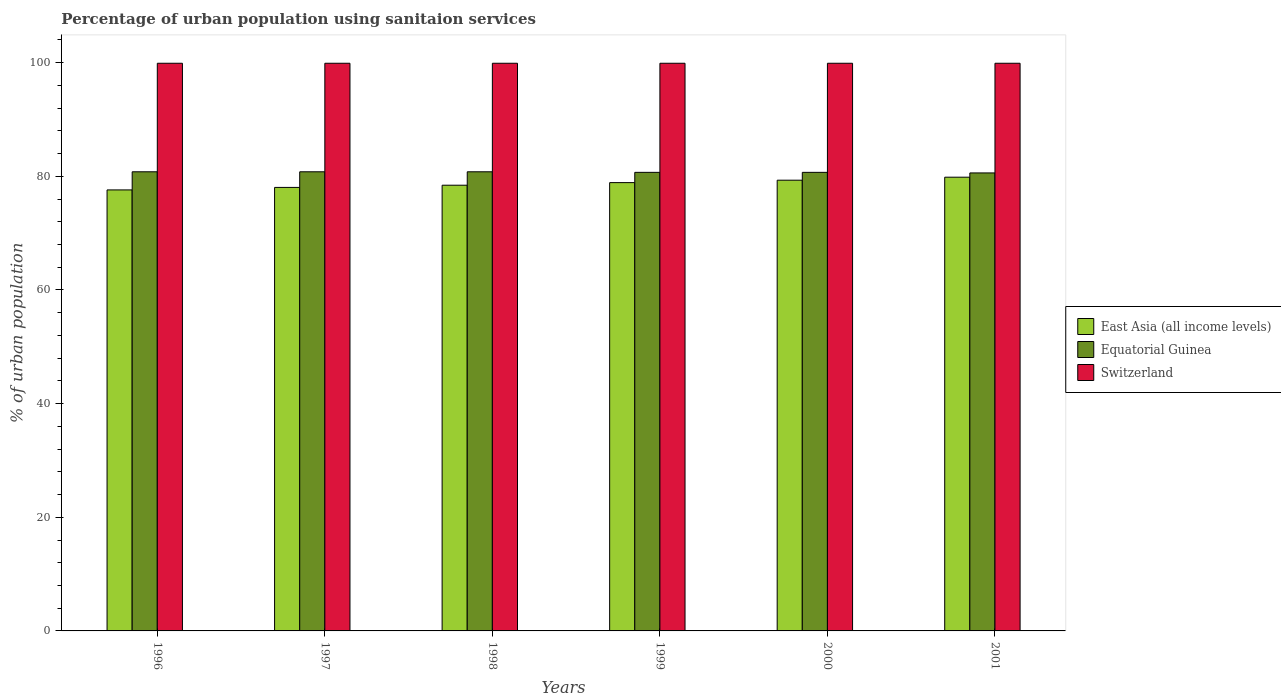How many groups of bars are there?
Offer a terse response. 6. What is the label of the 1st group of bars from the left?
Make the answer very short. 1996. What is the percentage of urban population using sanitaion services in Switzerland in 1998?
Your answer should be very brief. 99.9. Across all years, what is the maximum percentage of urban population using sanitaion services in East Asia (all income levels)?
Offer a very short reply. 79.85. Across all years, what is the minimum percentage of urban population using sanitaion services in Switzerland?
Provide a succinct answer. 99.9. In which year was the percentage of urban population using sanitaion services in Equatorial Guinea maximum?
Provide a succinct answer. 1996. What is the total percentage of urban population using sanitaion services in Switzerland in the graph?
Your answer should be very brief. 599.4. What is the difference between the percentage of urban population using sanitaion services in Equatorial Guinea in 1998 and that in 1999?
Your answer should be compact. 0.1. What is the difference between the percentage of urban population using sanitaion services in Switzerland in 1998 and the percentage of urban population using sanitaion services in East Asia (all income levels) in 1999?
Offer a very short reply. 21. What is the average percentage of urban population using sanitaion services in Equatorial Guinea per year?
Provide a succinct answer. 80.73. In the year 1999, what is the difference between the percentage of urban population using sanitaion services in Equatorial Guinea and percentage of urban population using sanitaion services in Switzerland?
Ensure brevity in your answer.  -19.2. In how many years, is the percentage of urban population using sanitaion services in East Asia (all income levels) greater than 20 %?
Offer a terse response. 6. What is the ratio of the percentage of urban population using sanitaion services in East Asia (all income levels) in 1999 to that in 2001?
Your answer should be very brief. 0.99. Is the percentage of urban population using sanitaion services in Switzerland in 1999 less than that in 2001?
Provide a short and direct response. No. Is the difference between the percentage of urban population using sanitaion services in Equatorial Guinea in 1999 and 2000 greater than the difference between the percentage of urban population using sanitaion services in Switzerland in 1999 and 2000?
Keep it short and to the point. No. What is the difference between the highest and the lowest percentage of urban population using sanitaion services in Switzerland?
Make the answer very short. 0. In how many years, is the percentage of urban population using sanitaion services in Equatorial Guinea greater than the average percentage of urban population using sanitaion services in Equatorial Guinea taken over all years?
Give a very brief answer. 3. What does the 2nd bar from the left in 2000 represents?
Offer a very short reply. Equatorial Guinea. What does the 2nd bar from the right in 2000 represents?
Make the answer very short. Equatorial Guinea. How many bars are there?
Ensure brevity in your answer.  18. How many years are there in the graph?
Ensure brevity in your answer.  6. What is the difference between two consecutive major ticks on the Y-axis?
Your answer should be very brief. 20. Does the graph contain any zero values?
Offer a very short reply. No. Where does the legend appear in the graph?
Keep it short and to the point. Center right. How many legend labels are there?
Provide a short and direct response. 3. What is the title of the graph?
Provide a succinct answer. Percentage of urban population using sanitaion services. What is the label or title of the X-axis?
Your response must be concise. Years. What is the label or title of the Y-axis?
Your answer should be very brief. % of urban population. What is the % of urban population of East Asia (all income levels) in 1996?
Offer a very short reply. 77.61. What is the % of urban population in Equatorial Guinea in 1996?
Ensure brevity in your answer.  80.8. What is the % of urban population in Switzerland in 1996?
Your answer should be very brief. 99.9. What is the % of urban population in East Asia (all income levels) in 1997?
Your response must be concise. 78.05. What is the % of urban population in Equatorial Guinea in 1997?
Provide a short and direct response. 80.8. What is the % of urban population of Switzerland in 1997?
Your response must be concise. 99.9. What is the % of urban population of East Asia (all income levels) in 1998?
Your answer should be very brief. 78.44. What is the % of urban population in Equatorial Guinea in 1998?
Ensure brevity in your answer.  80.8. What is the % of urban population in Switzerland in 1998?
Keep it short and to the point. 99.9. What is the % of urban population of East Asia (all income levels) in 1999?
Your response must be concise. 78.9. What is the % of urban population in Equatorial Guinea in 1999?
Your answer should be compact. 80.7. What is the % of urban population of Switzerland in 1999?
Your answer should be compact. 99.9. What is the % of urban population of East Asia (all income levels) in 2000?
Provide a succinct answer. 79.32. What is the % of urban population of Equatorial Guinea in 2000?
Provide a succinct answer. 80.7. What is the % of urban population in Switzerland in 2000?
Offer a terse response. 99.9. What is the % of urban population in East Asia (all income levels) in 2001?
Your response must be concise. 79.85. What is the % of urban population of Equatorial Guinea in 2001?
Offer a very short reply. 80.6. What is the % of urban population of Switzerland in 2001?
Give a very brief answer. 99.9. Across all years, what is the maximum % of urban population in East Asia (all income levels)?
Offer a very short reply. 79.85. Across all years, what is the maximum % of urban population in Equatorial Guinea?
Ensure brevity in your answer.  80.8. Across all years, what is the maximum % of urban population of Switzerland?
Offer a very short reply. 99.9. Across all years, what is the minimum % of urban population in East Asia (all income levels)?
Provide a succinct answer. 77.61. Across all years, what is the minimum % of urban population of Equatorial Guinea?
Give a very brief answer. 80.6. Across all years, what is the minimum % of urban population of Switzerland?
Keep it short and to the point. 99.9. What is the total % of urban population of East Asia (all income levels) in the graph?
Offer a terse response. 472.17. What is the total % of urban population in Equatorial Guinea in the graph?
Ensure brevity in your answer.  484.4. What is the total % of urban population of Switzerland in the graph?
Offer a terse response. 599.4. What is the difference between the % of urban population in East Asia (all income levels) in 1996 and that in 1997?
Provide a short and direct response. -0.44. What is the difference between the % of urban population in Equatorial Guinea in 1996 and that in 1997?
Your response must be concise. 0. What is the difference between the % of urban population in East Asia (all income levels) in 1996 and that in 1998?
Provide a short and direct response. -0.83. What is the difference between the % of urban population in Equatorial Guinea in 1996 and that in 1998?
Give a very brief answer. 0. What is the difference between the % of urban population in East Asia (all income levels) in 1996 and that in 1999?
Your response must be concise. -1.28. What is the difference between the % of urban population of Switzerland in 1996 and that in 1999?
Your answer should be very brief. 0. What is the difference between the % of urban population in East Asia (all income levels) in 1996 and that in 2000?
Give a very brief answer. -1.71. What is the difference between the % of urban population of Switzerland in 1996 and that in 2000?
Offer a terse response. 0. What is the difference between the % of urban population in East Asia (all income levels) in 1996 and that in 2001?
Provide a succinct answer. -2.24. What is the difference between the % of urban population in Equatorial Guinea in 1996 and that in 2001?
Keep it short and to the point. 0.2. What is the difference between the % of urban population of Switzerland in 1996 and that in 2001?
Provide a succinct answer. 0. What is the difference between the % of urban population of East Asia (all income levels) in 1997 and that in 1998?
Your answer should be compact. -0.39. What is the difference between the % of urban population of East Asia (all income levels) in 1997 and that in 1999?
Provide a succinct answer. -0.85. What is the difference between the % of urban population in Equatorial Guinea in 1997 and that in 1999?
Your response must be concise. 0.1. What is the difference between the % of urban population in East Asia (all income levels) in 1997 and that in 2000?
Make the answer very short. -1.27. What is the difference between the % of urban population in Equatorial Guinea in 1997 and that in 2000?
Keep it short and to the point. 0.1. What is the difference between the % of urban population in East Asia (all income levels) in 1997 and that in 2001?
Your answer should be compact. -1.8. What is the difference between the % of urban population of Equatorial Guinea in 1997 and that in 2001?
Your answer should be very brief. 0.2. What is the difference between the % of urban population of East Asia (all income levels) in 1998 and that in 1999?
Offer a very short reply. -0.46. What is the difference between the % of urban population of Switzerland in 1998 and that in 1999?
Your answer should be compact. 0. What is the difference between the % of urban population of East Asia (all income levels) in 1998 and that in 2000?
Ensure brevity in your answer.  -0.88. What is the difference between the % of urban population in Switzerland in 1998 and that in 2000?
Your answer should be compact. 0. What is the difference between the % of urban population in East Asia (all income levels) in 1998 and that in 2001?
Ensure brevity in your answer.  -1.41. What is the difference between the % of urban population of Equatorial Guinea in 1998 and that in 2001?
Ensure brevity in your answer.  0.2. What is the difference between the % of urban population of Switzerland in 1998 and that in 2001?
Ensure brevity in your answer.  0. What is the difference between the % of urban population in East Asia (all income levels) in 1999 and that in 2000?
Make the answer very short. -0.43. What is the difference between the % of urban population in Equatorial Guinea in 1999 and that in 2000?
Keep it short and to the point. 0. What is the difference between the % of urban population of Switzerland in 1999 and that in 2000?
Your answer should be compact. 0. What is the difference between the % of urban population in East Asia (all income levels) in 1999 and that in 2001?
Make the answer very short. -0.95. What is the difference between the % of urban population in East Asia (all income levels) in 2000 and that in 2001?
Your response must be concise. -0.53. What is the difference between the % of urban population of Switzerland in 2000 and that in 2001?
Provide a succinct answer. 0. What is the difference between the % of urban population of East Asia (all income levels) in 1996 and the % of urban population of Equatorial Guinea in 1997?
Your answer should be very brief. -3.19. What is the difference between the % of urban population of East Asia (all income levels) in 1996 and the % of urban population of Switzerland in 1997?
Ensure brevity in your answer.  -22.29. What is the difference between the % of urban population of Equatorial Guinea in 1996 and the % of urban population of Switzerland in 1997?
Offer a very short reply. -19.1. What is the difference between the % of urban population of East Asia (all income levels) in 1996 and the % of urban population of Equatorial Guinea in 1998?
Your answer should be compact. -3.19. What is the difference between the % of urban population of East Asia (all income levels) in 1996 and the % of urban population of Switzerland in 1998?
Offer a very short reply. -22.29. What is the difference between the % of urban population of Equatorial Guinea in 1996 and the % of urban population of Switzerland in 1998?
Offer a very short reply. -19.1. What is the difference between the % of urban population of East Asia (all income levels) in 1996 and the % of urban population of Equatorial Guinea in 1999?
Ensure brevity in your answer.  -3.09. What is the difference between the % of urban population in East Asia (all income levels) in 1996 and the % of urban population in Switzerland in 1999?
Your answer should be very brief. -22.29. What is the difference between the % of urban population in Equatorial Guinea in 1996 and the % of urban population in Switzerland in 1999?
Your answer should be very brief. -19.1. What is the difference between the % of urban population of East Asia (all income levels) in 1996 and the % of urban population of Equatorial Guinea in 2000?
Your response must be concise. -3.09. What is the difference between the % of urban population in East Asia (all income levels) in 1996 and the % of urban population in Switzerland in 2000?
Your answer should be compact. -22.29. What is the difference between the % of urban population in Equatorial Guinea in 1996 and the % of urban population in Switzerland in 2000?
Ensure brevity in your answer.  -19.1. What is the difference between the % of urban population of East Asia (all income levels) in 1996 and the % of urban population of Equatorial Guinea in 2001?
Ensure brevity in your answer.  -2.99. What is the difference between the % of urban population in East Asia (all income levels) in 1996 and the % of urban population in Switzerland in 2001?
Make the answer very short. -22.29. What is the difference between the % of urban population of Equatorial Guinea in 1996 and the % of urban population of Switzerland in 2001?
Offer a terse response. -19.1. What is the difference between the % of urban population in East Asia (all income levels) in 1997 and the % of urban population in Equatorial Guinea in 1998?
Keep it short and to the point. -2.75. What is the difference between the % of urban population in East Asia (all income levels) in 1997 and the % of urban population in Switzerland in 1998?
Provide a short and direct response. -21.85. What is the difference between the % of urban population in Equatorial Guinea in 1997 and the % of urban population in Switzerland in 1998?
Offer a very short reply. -19.1. What is the difference between the % of urban population in East Asia (all income levels) in 1997 and the % of urban population in Equatorial Guinea in 1999?
Provide a short and direct response. -2.65. What is the difference between the % of urban population of East Asia (all income levels) in 1997 and the % of urban population of Switzerland in 1999?
Keep it short and to the point. -21.85. What is the difference between the % of urban population in Equatorial Guinea in 1997 and the % of urban population in Switzerland in 1999?
Keep it short and to the point. -19.1. What is the difference between the % of urban population in East Asia (all income levels) in 1997 and the % of urban population in Equatorial Guinea in 2000?
Offer a terse response. -2.65. What is the difference between the % of urban population of East Asia (all income levels) in 1997 and the % of urban population of Switzerland in 2000?
Your answer should be very brief. -21.85. What is the difference between the % of urban population in Equatorial Guinea in 1997 and the % of urban population in Switzerland in 2000?
Your response must be concise. -19.1. What is the difference between the % of urban population in East Asia (all income levels) in 1997 and the % of urban population in Equatorial Guinea in 2001?
Offer a terse response. -2.55. What is the difference between the % of urban population in East Asia (all income levels) in 1997 and the % of urban population in Switzerland in 2001?
Ensure brevity in your answer.  -21.85. What is the difference between the % of urban population in Equatorial Guinea in 1997 and the % of urban population in Switzerland in 2001?
Ensure brevity in your answer.  -19.1. What is the difference between the % of urban population in East Asia (all income levels) in 1998 and the % of urban population in Equatorial Guinea in 1999?
Your answer should be compact. -2.26. What is the difference between the % of urban population of East Asia (all income levels) in 1998 and the % of urban population of Switzerland in 1999?
Your answer should be compact. -21.46. What is the difference between the % of urban population in Equatorial Guinea in 1998 and the % of urban population in Switzerland in 1999?
Your answer should be very brief. -19.1. What is the difference between the % of urban population in East Asia (all income levels) in 1998 and the % of urban population in Equatorial Guinea in 2000?
Provide a short and direct response. -2.26. What is the difference between the % of urban population of East Asia (all income levels) in 1998 and the % of urban population of Switzerland in 2000?
Your answer should be compact. -21.46. What is the difference between the % of urban population of Equatorial Guinea in 1998 and the % of urban population of Switzerland in 2000?
Offer a terse response. -19.1. What is the difference between the % of urban population in East Asia (all income levels) in 1998 and the % of urban population in Equatorial Guinea in 2001?
Keep it short and to the point. -2.16. What is the difference between the % of urban population of East Asia (all income levels) in 1998 and the % of urban population of Switzerland in 2001?
Make the answer very short. -21.46. What is the difference between the % of urban population of Equatorial Guinea in 1998 and the % of urban population of Switzerland in 2001?
Provide a short and direct response. -19.1. What is the difference between the % of urban population of East Asia (all income levels) in 1999 and the % of urban population of Equatorial Guinea in 2000?
Give a very brief answer. -1.8. What is the difference between the % of urban population of East Asia (all income levels) in 1999 and the % of urban population of Switzerland in 2000?
Your response must be concise. -21. What is the difference between the % of urban population of Equatorial Guinea in 1999 and the % of urban population of Switzerland in 2000?
Make the answer very short. -19.2. What is the difference between the % of urban population of East Asia (all income levels) in 1999 and the % of urban population of Equatorial Guinea in 2001?
Make the answer very short. -1.7. What is the difference between the % of urban population of East Asia (all income levels) in 1999 and the % of urban population of Switzerland in 2001?
Ensure brevity in your answer.  -21. What is the difference between the % of urban population of Equatorial Guinea in 1999 and the % of urban population of Switzerland in 2001?
Ensure brevity in your answer.  -19.2. What is the difference between the % of urban population in East Asia (all income levels) in 2000 and the % of urban population in Equatorial Guinea in 2001?
Ensure brevity in your answer.  -1.28. What is the difference between the % of urban population of East Asia (all income levels) in 2000 and the % of urban population of Switzerland in 2001?
Your response must be concise. -20.58. What is the difference between the % of urban population in Equatorial Guinea in 2000 and the % of urban population in Switzerland in 2001?
Keep it short and to the point. -19.2. What is the average % of urban population of East Asia (all income levels) per year?
Keep it short and to the point. 78.69. What is the average % of urban population in Equatorial Guinea per year?
Ensure brevity in your answer.  80.73. What is the average % of urban population of Switzerland per year?
Your response must be concise. 99.9. In the year 1996, what is the difference between the % of urban population of East Asia (all income levels) and % of urban population of Equatorial Guinea?
Keep it short and to the point. -3.19. In the year 1996, what is the difference between the % of urban population of East Asia (all income levels) and % of urban population of Switzerland?
Offer a terse response. -22.29. In the year 1996, what is the difference between the % of urban population in Equatorial Guinea and % of urban population in Switzerland?
Offer a very short reply. -19.1. In the year 1997, what is the difference between the % of urban population in East Asia (all income levels) and % of urban population in Equatorial Guinea?
Your response must be concise. -2.75. In the year 1997, what is the difference between the % of urban population in East Asia (all income levels) and % of urban population in Switzerland?
Offer a terse response. -21.85. In the year 1997, what is the difference between the % of urban population in Equatorial Guinea and % of urban population in Switzerland?
Provide a short and direct response. -19.1. In the year 1998, what is the difference between the % of urban population in East Asia (all income levels) and % of urban population in Equatorial Guinea?
Offer a very short reply. -2.36. In the year 1998, what is the difference between the % of urban population of East Asia (all income levels) and % of urban population of Switzerland?
Offer a very short reply. -21.46. In the year 1998, what is the difference between the % of urban population in Equatorial Guinea and % of urban population in Switzerland?
Provide a short and direct response. -19.1. In the year 1999, what is the difference between the % of urban population of East Asia (all income levels) and % of urban population of Equatorial Guinea?
Provide a short and direct response. -1.8. In the year 1999, what is the difference between the % of urban population in East Asia (all income levels) and % of urban population in Switzerland?
Your answer should be compact. -21. In the year 1999, what is the difference between the % of urban population of Equatorial Guinea and % of urban population of Switzerland?
Your answer should be very brief. -19.2. In the year 2000, what is the difference between the % of urban population in East Asia (all income levels) and % of urban population in Equatorial Guinea?
Keep it short and to the point. -1.38. In the year 2000, what is the difference between the % of urban population in East Asia (all income levels) and % of urban population in Switzerland?
Make the answer very short. -20.58. In the year 2000, what is the difference between the % of urban population in Equatorial Guinea and % of urban population in Switzerland?
Your response must be concise. -19.2. In the year 2001, what is the difference between the % of urban population of East Asia (all income levels) and % of urban population of Equatorial Guinea?
Offer a terse response. -0.75. In the year 2001, what is the difference between the % of urban population of East Asia (all income levels) and % of urban population of Switzerland?
Provide a succinct answer. -20.05. In the year 2001, what is the difference between the % of urban population of Equatorial Guinea and % of urban population of Switzerland?
Provide a succinct answer. -19.3. What is the ratio of the % of urban population of East Asia (all income levels) in 1996 to that in 1997?
Your response must be concise. 0.99. What is the ratio of the % of urban population of Switzerland in 1996 to that in 1997?
Offer a very short reply. 1. What is the ratio of the % of urban population in Equatorial Guinea in 1996 to that in 1998?
Your answer should be compact. 1. What is the ratio of the % of urban population of Switzerland in 1996 to that in 1998?
Your answer should be very brief. 1. What is the ratio of the % of urban population of East Asia (all income levels) in 1996 to that in 1999?
Make the answer very short. 0.98. What is the ratio of the % of urban population in Equatorial Guinea in 1996 to that in 1999?
Keep it short and to the point. 1. What is the ratio of the % of urban population of East Asia (all income levels) in 1996 to that in 2000?
Ensure brevity in your answer.  0.98. What is the ratio of the % of urban population of Equatorial Guinea in 1996 to that in 2000?
Your answer should be compact. 1. What is the ratio of the % of urban population in East Asia (all income levels) in 1996 to that in 2001?
Make the answer very short. 0.97. What is the ratio of the % of urban population of Switzerland in 1996 to that in 2001?
Offer a very short reply. 1. What is the ratio of the % of urban population in East Asia (all income levels) in 1997 to that in 1998?
Give a very brief answer. 0.99. What is the ratio of the % of urban population in Switzerland in 1997 to that in 1998?
Ensure brevity in your answer.  1. What is the ratio of the % of urban population in East Asia (all income levels) in 1997 to that in 1999?
Make the answer very short. 0.99. What is the ratio of the % of urban population of East Asia (all income levels) in 1997 to that in 2001?
Make the answer very short. 0.98. What is the ratio of the % of urban population in Switzerland in 1997 to that in 2001?
Offer a very short reply. 1. What is the ratio of the % of urban population in Switzerland in 1998 to that in 1999?
Provide a succinct answer. 1. What is the ratio of the % of urban population in East Asia (all income levels) in 1998 to that in 2000?
Your response must be concise. 0.99. What is the ratio of the % of urban population in East Asia (all income levels) in 1998 to that in 2001?
Offer a terse response. 0.98. What is the ratio of the % of urban population of Equatorial Guinea in 1998 to that in 2001?
Ensure brevity in your answer.  1. What is the ratio of the % of urban population in East Asia (all income levels) in 1999 to that in 2001?
Make the answer very short. 0.99. What is the ratio of the % of urban population in Switzerland in 1999 to that in 2001?
Offer a very short reply. 1. What is the ratio of the % of urban population of East Asia (all income levels) in 2000 to that in 2001?
Ensure brevity in your answer.  0.99. What is the ratio of the % of urban population of Switzerland in 2000 to that in 2001?
Provide a short and direct response. 1. What is the difference between the highest and the second highest % of urban population in East Asia (all income levels)?
Offer a terse response. 0.53. What is the difference between the highest and the second highest % of urban population of Equatorial Guinea?
Offer a terse response. 0. What is the difference between the highest and the second highest % of urban population in Switzerland?
Offer a terse response. 0. What is the difference between the highest and the lowest % of urban population in East Asia (all income levels)?
Keep it short and to the point. 2.24. What is the difference between the highest and the lowest % of urban population in Equatorial Guinea?
Offer a terse response. 0.2. 